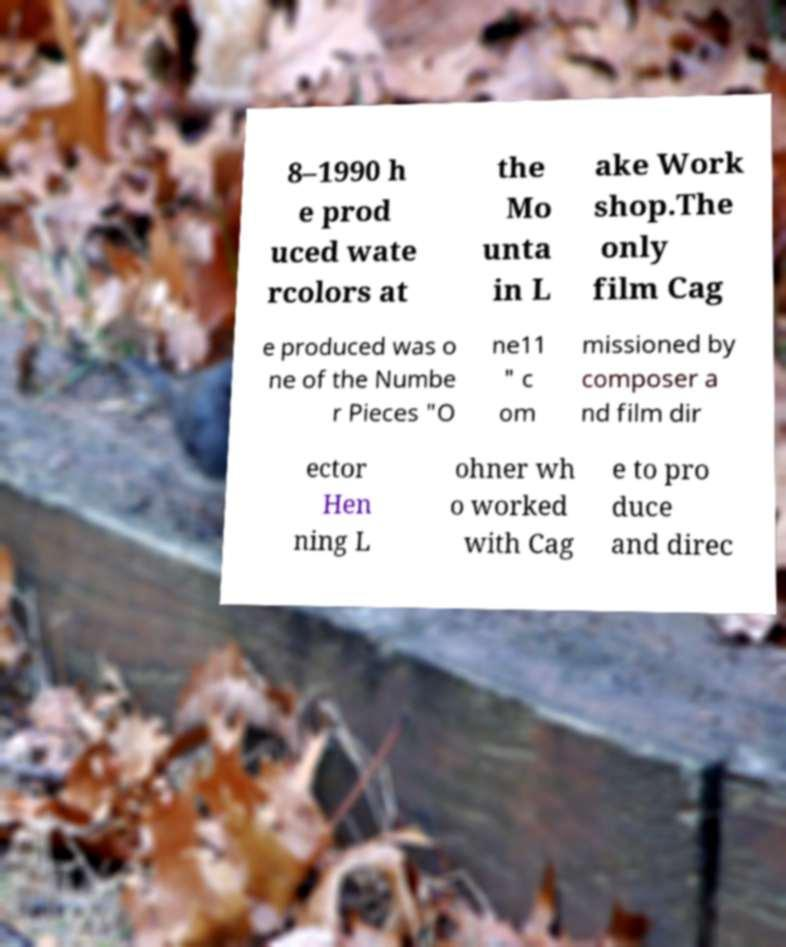Please identify and transcribe the text found in this image. 8–1990 h e prod uced wate rcolors at the Mo unta in L ake Work shop.The only film Cag e produced was o ne of the Numbe r Pieces "O ne11 " c om missioned by composer a nd film dir ector Hen ning L ohner wh o worked with Cag e to pro duce and direc 